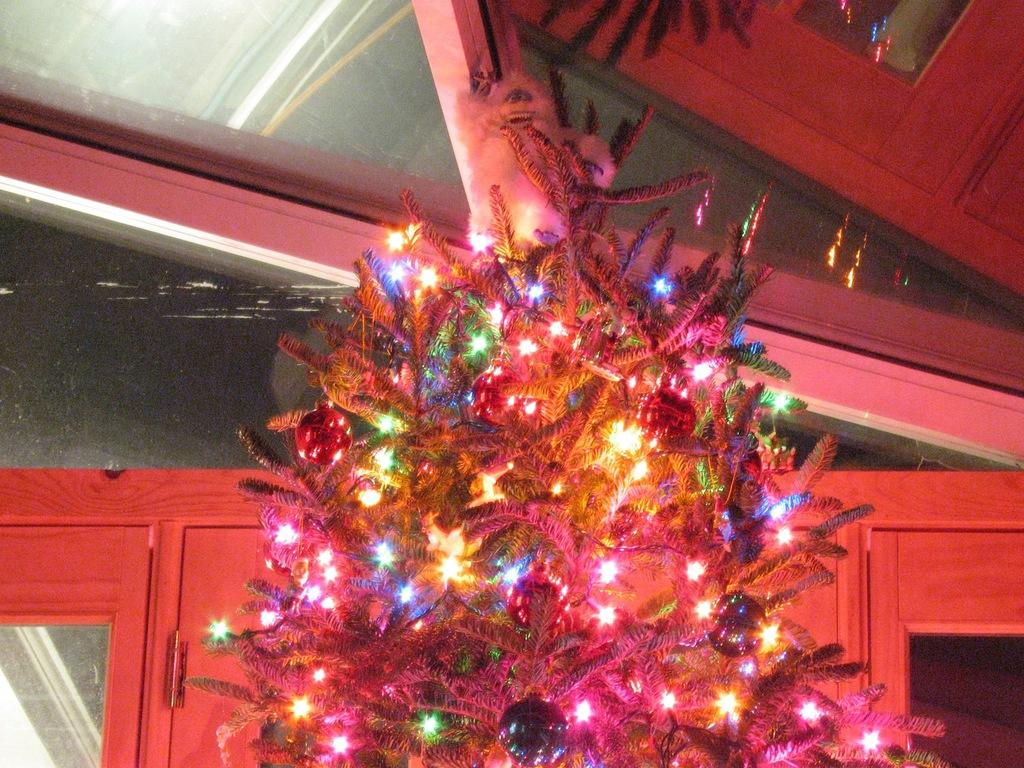What is the main subject of the image? There is a Christmas tree in the image. What else can be seen in the image besides the Christmas tree? There are decorative items and multi-colored lights in the image. What type of doors are visible in the background of the image? There are glass doors in the background of the image. What type of soap is displayed on the Christmas tree in the image? There is no soap present in the image; it features a Christmas tree with decorative items and multi-colored lights. What is the selection of buns available for purchase in the image? There is no mention of buns or any type of food in the image; it focuses on a Christmas tree and its decorations. 